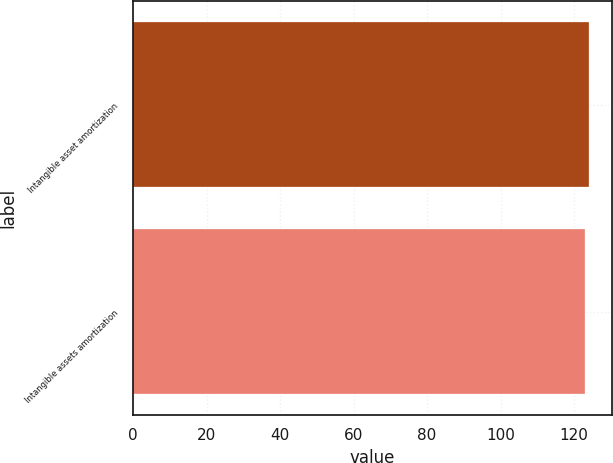Convert chart. <chart><loc_0><loc_0><loc_500><loc_500><bar_chart><fcel>Intangible asset amortization<fcel>Intangible assets amortization<nl><fcel>124<fcel>123<nl></chart> 